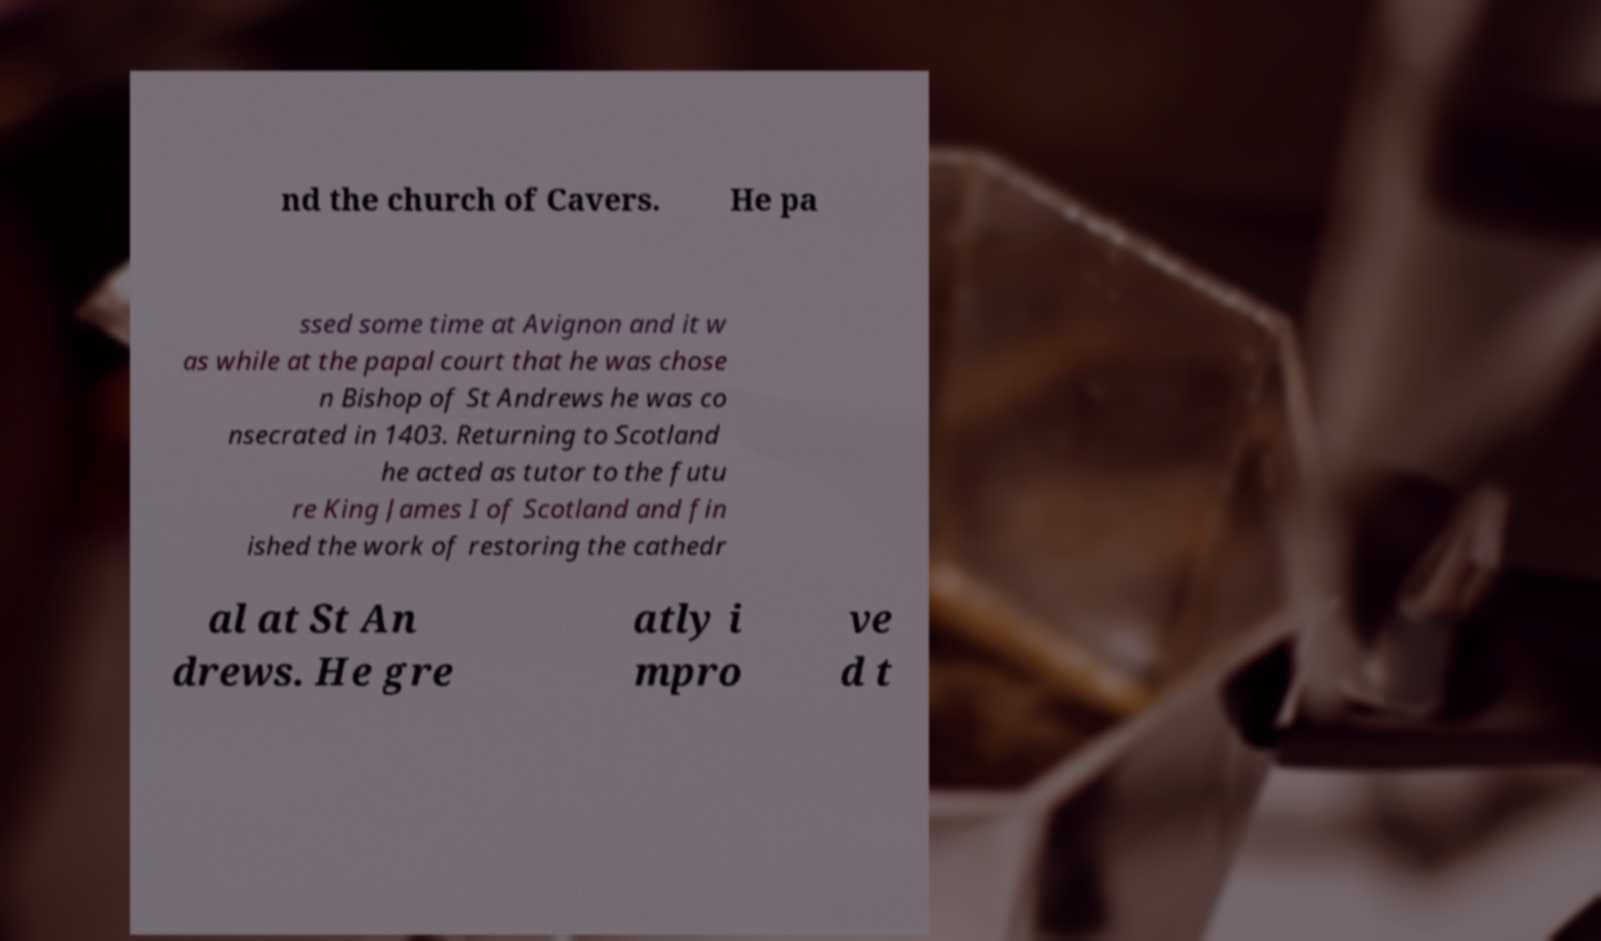Please read and relay the text visible in this image. What does it say? nd the church of Cavers. He pa ssed some time at Avignon and it w as while at the papal court that he was chose n Bishop of St Andrews he was co nsecrated in 1403. Returning to Scotland he acted as tutor to the futu re King James I of Scotland and fin ished the work of restoring the cathedr al at St An drews. He gre atly i mpro ve d t 